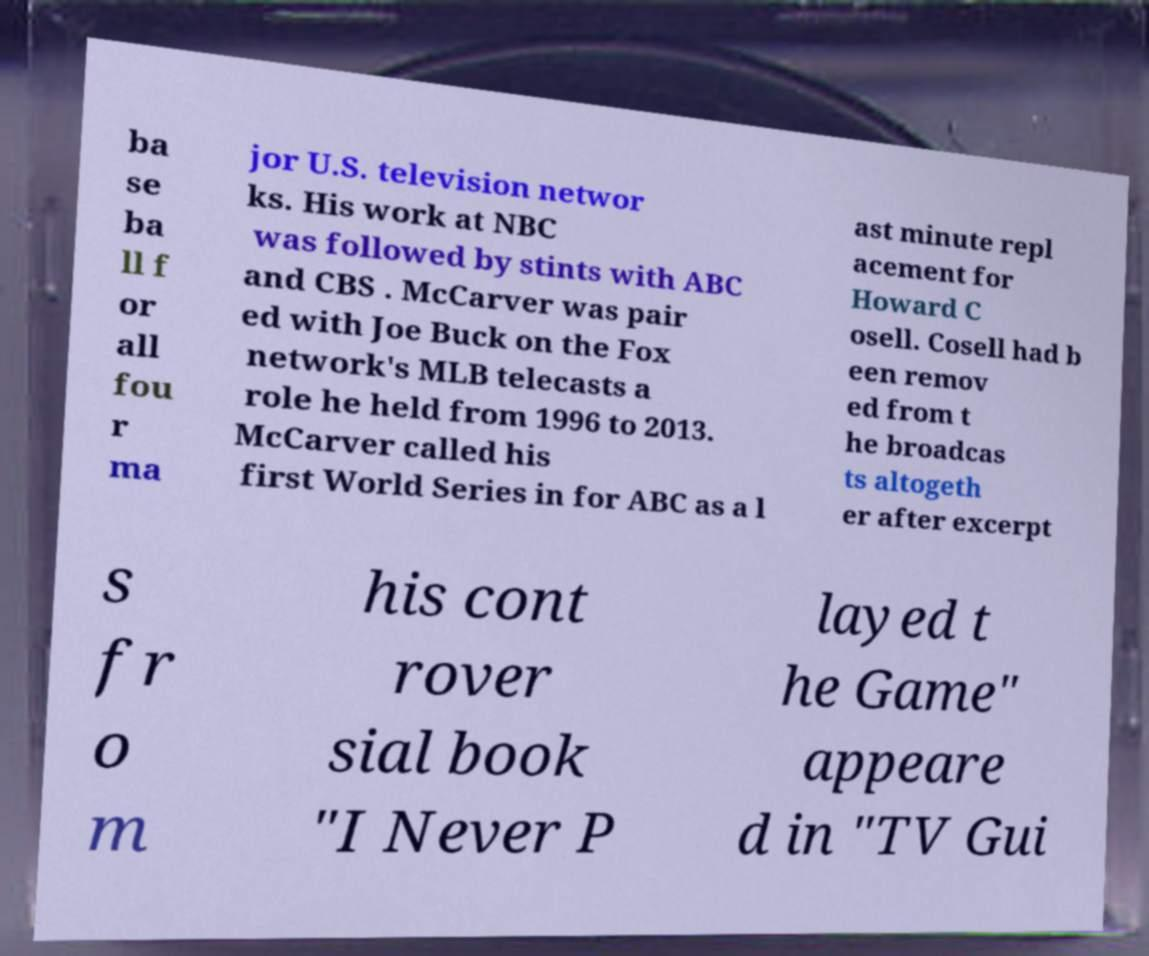I need the written content from this picture converted into text. Can you do that? ba se ba ll f or all fou r ma jor U.S. television networ ks. His work at NBC was followed by stints with ABC and CBS . McCarver was pair ed with Joe Buck on the Fox network's MLB telecasts a role he held from 1996 to 2013. McCarver called his first World Series in for ABC as a l ast minute repl acement for Howard C osell. Cosell had b een remov ed from t he broadcas ts altogeth er after excerpt s fr o m his cont rover sial book "I Never P layed t he Game" appeare d in "TV Gui 